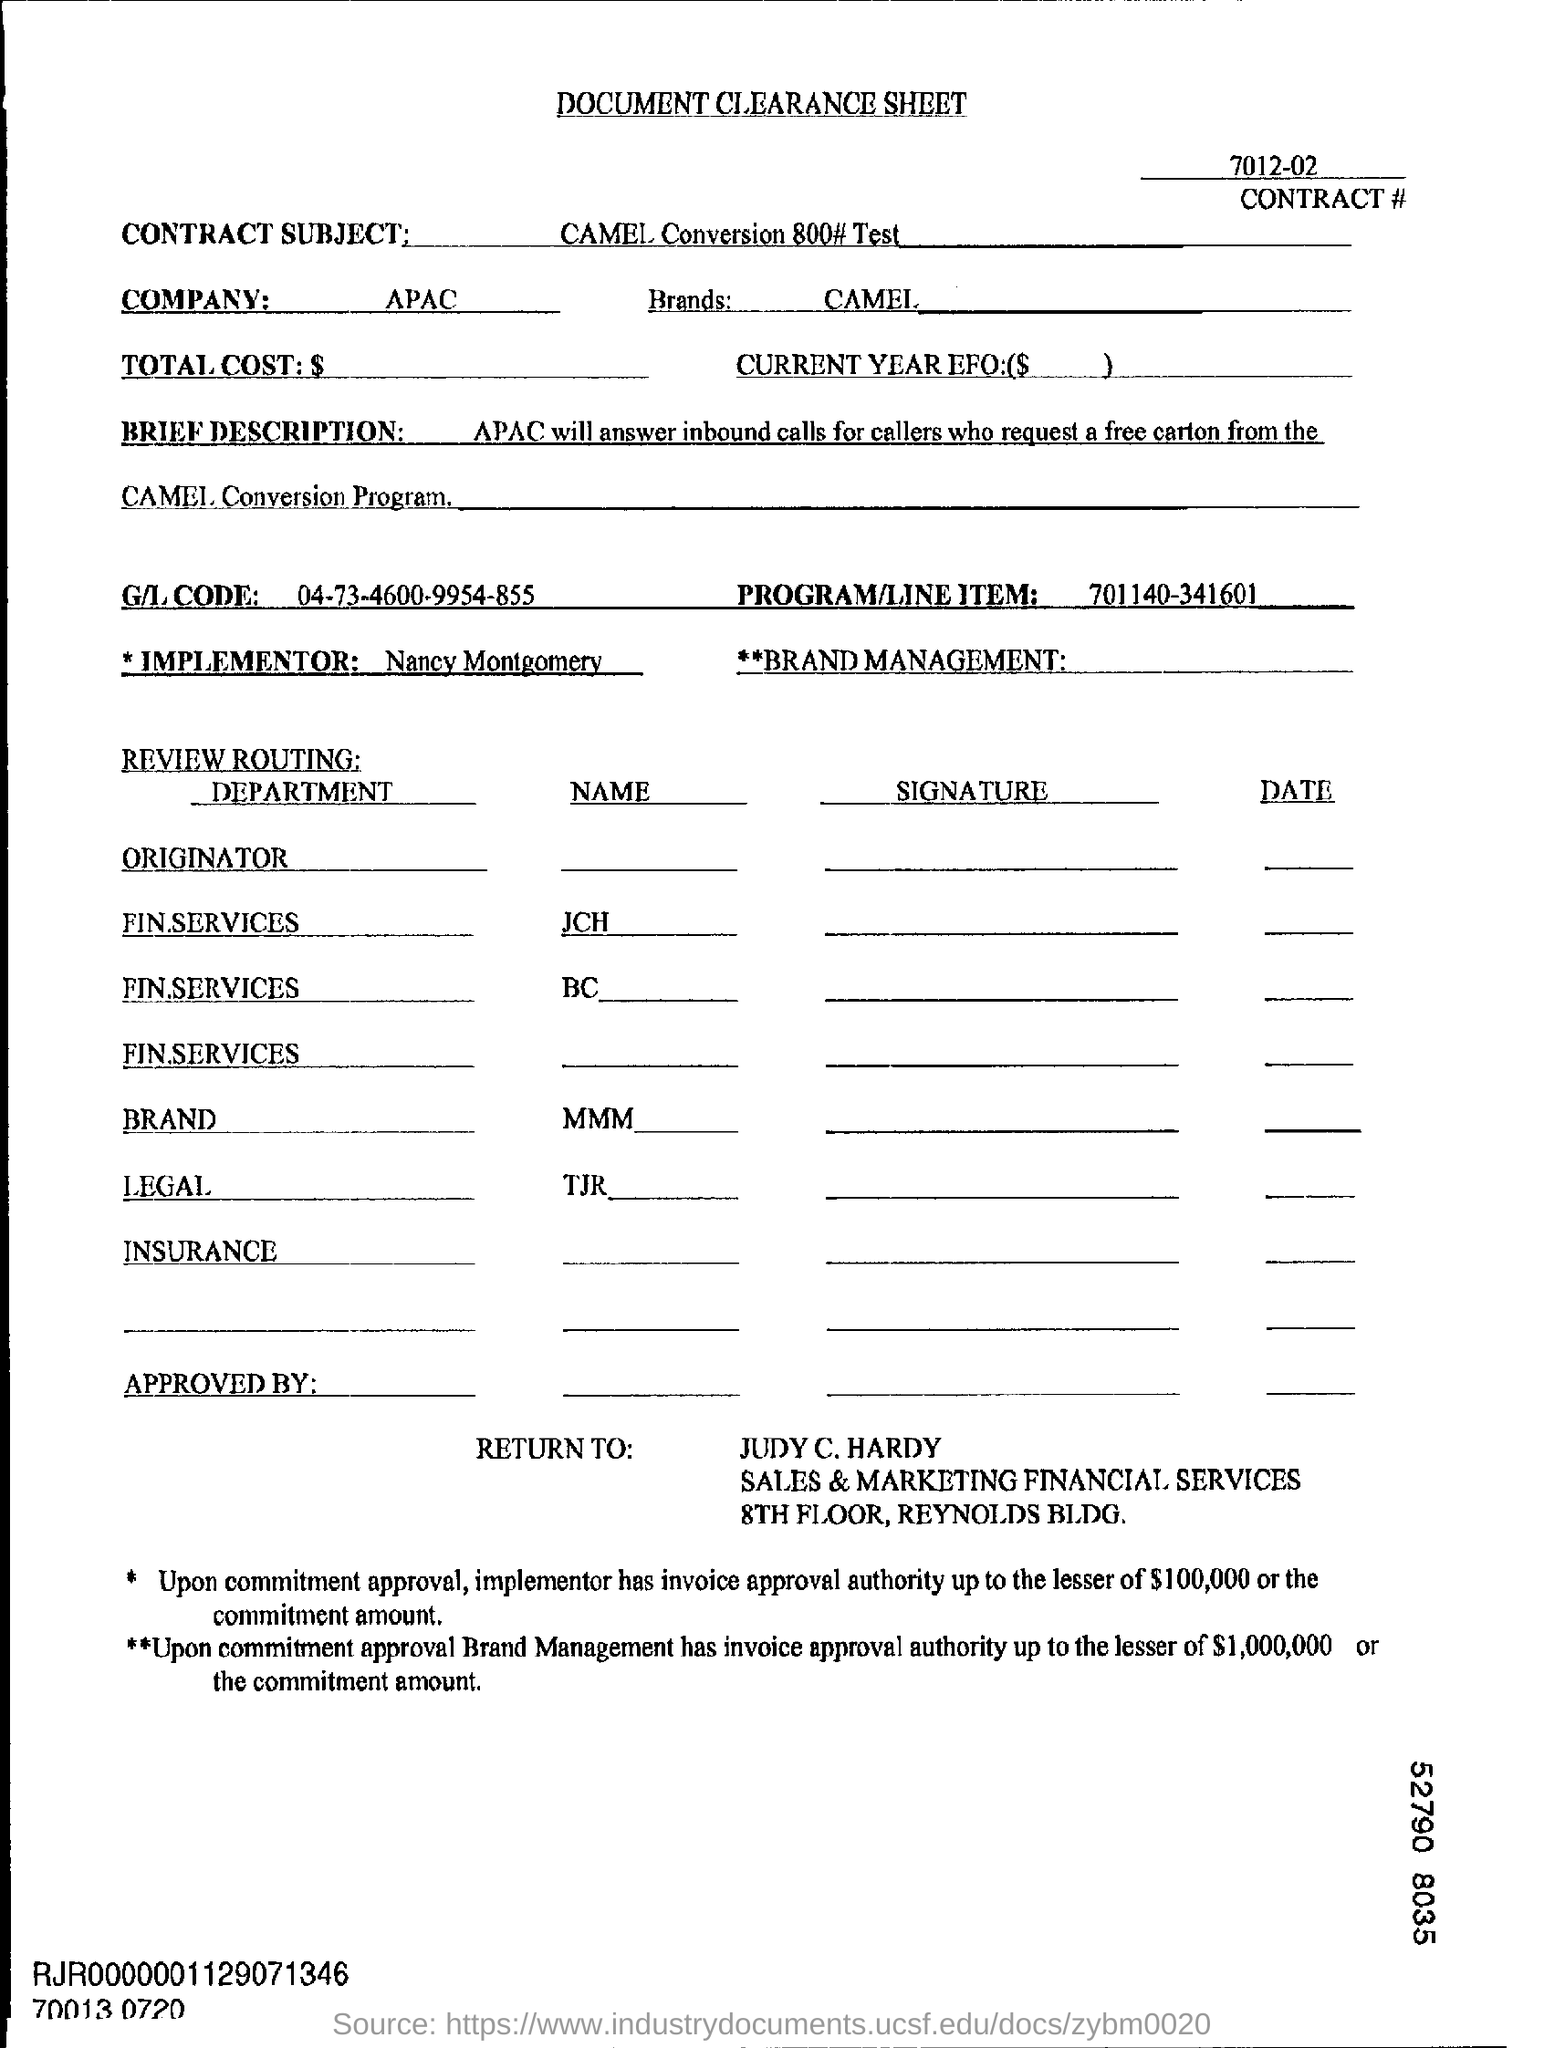What is the Company Name ?
Ensure brevity in your answer.  APAC. What is mentioned in the Program/Line Item Filed ?
Make the answer very short. 701140-341601. 